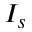<formula> <loc_0><loc_0><loc_500><loc_500>I _ { s }</formula> 